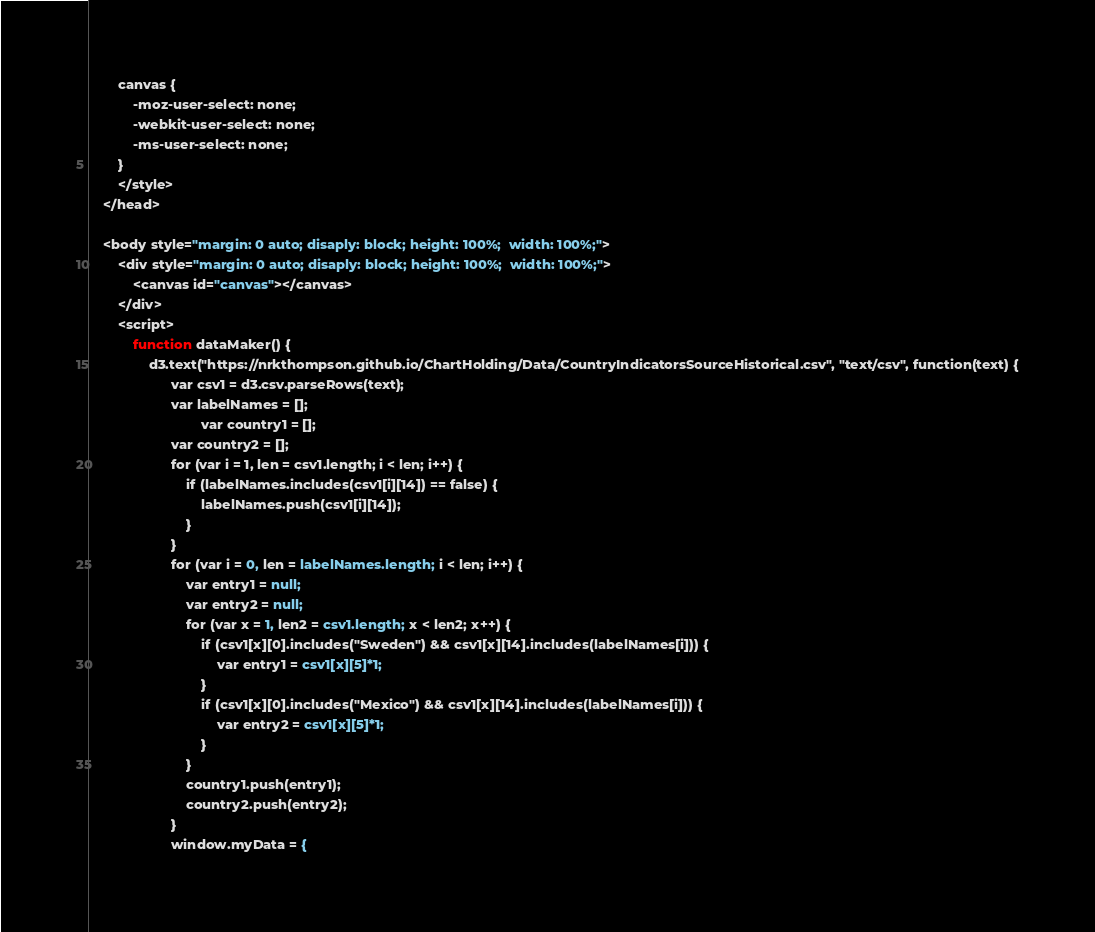Convert code to text. <code><loc_0><loc_0><loc_500><loc_500><_HTML_>		canvas {
			-moz-user-select: none;
			-webkit-user-select: none;
			-ms-user-select: none;
		}
		</style>
	</head>

	<body style="margin: 0 auto; disaply: block; height: 100%;  width: 100%;">
		<div style="margin: 0 auto; disaply: block; height: 100%;  width: 100%;">
			<canvas id="canvas"></canvas>
		</div>
		<script>
			function dataMaker() {
				d3.text("https://nrkthompson.github.io/ChartHolding/Data/CountryIndicatorsSourceHistorical.csv", "text/csv", function(text) {
					  var csv1 = d3.csv.parseRows(text);
					  var labelNames = [];
            				  var country1 = [];
					  var country2 = [];
					  for (var i = 1, len = csv1.length; i < len; i++) {
						  if (labelNames.includes(csv1[i][14]) == false) {
							  labelNames.push(csv1[i][14]);
						  }
					  }
					  for (var i = 0, len = labelNames.length; i < len; i++) {
						  var entry1 = null;
						  var entry2 = null;
						  for (var x = 1, len2 = csv1.length; x < len2; x++) {
							  if (csv1[x][0].includes("Sweden") && csv1[x][14].includes(labelNames[i])) {
								  var entry1 = csv1[x][5]*1;
							  }
							  if (csv1[x][0].includes("Mexico") && csv1[x][14].includes(labelNames[i])) {
								  var entry2 = csv1[x][5]*1;
							  }
						  }
						  country1.push(entry1);
						  country2.push(entry2);
					  }
					  window.myData = {</code> 